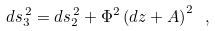<formula> <loc_0><loc_0><loc_500><loc_500>d s _ { 3 } ^ { \, 2 } = d s _ { 2 } ^ { \, 2 } + \Phi ^ { 2 } \left ( d z + A \right ) ^ { 2 } \ ,</formula> 